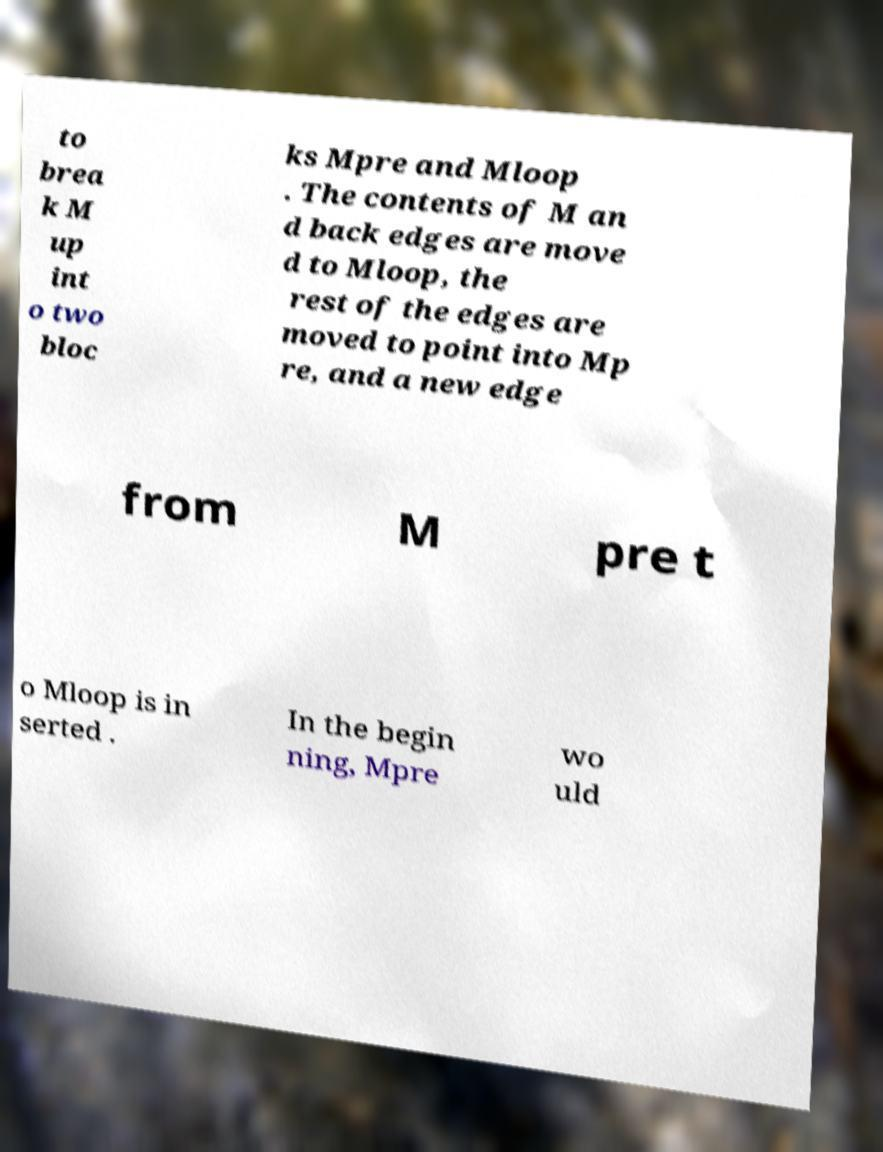For documentation purposes, I need the text within this image transcribed. Could you provide that? to brea k M up int o two bloc ks Mpre and Mloop . The contents of M an d back edges are move d to Mloop, the rest of the edges are moved to point into Mp re, and a new edge from M pre t o Mloop is in serted . In the begin ning, Mpre wo uld 